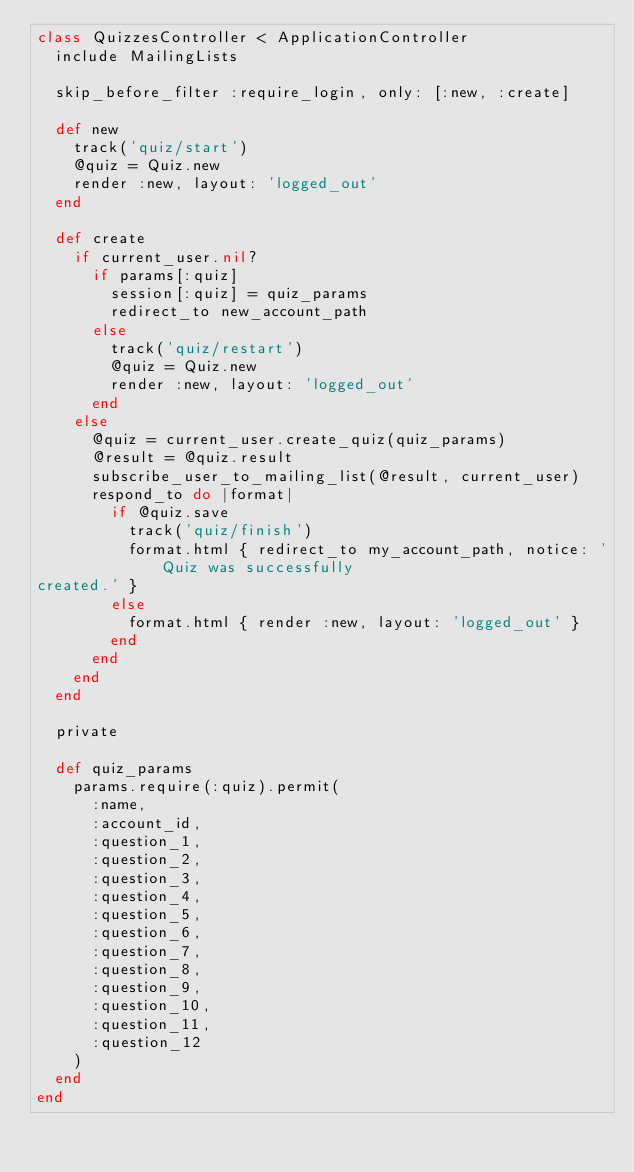Convert code to text. <code><loc_0><loc_0><loc_500><loc_500><_Ruby_>class QuizzesController < ApplicationController
  include MailingLists

  skip_before_filter :require_login, only: [:new, :create]

  def new
    track('quiz/start')
    @quiz = Quiz.new
    render :new, layout: 'logged_out'
  end

  def create
    if current_user.nil?
      if params[:quiz]
        session[:quiz] = quiz_params
        redirect_to new_account_path
      else
        track('quiz/restart')
        @quiz = Quiz.new
        render :new, layout: 'logged_out'
      end
    else
      @quiz = current_user.create_quiz(quiz_params)
      @result = @quiz.result
      subscribe_user_to_mailing_list(@result, current_user)
      respond_to do |format|
        if @quiz.save
          track('quiz/finish')
          format.html { redirect_to my_account_path, notice: 'Quiz was successfully
created.' }
        else
          format.html { render :new, layout: 'logged_out' }
        end
      end
    end
  end

  private

  def quiz_params
    params.require(:quiz).permit(
      :name,
      :account_id,
      :question_1,
      :question_2,
      :question_3,
      :question_4,
      :question_5,
      :question_6,
      :question_7,
      :question_8,
      :question_9,
      :question_10,
      :question_11,
      :question_12
    )
  end
end
</code> 